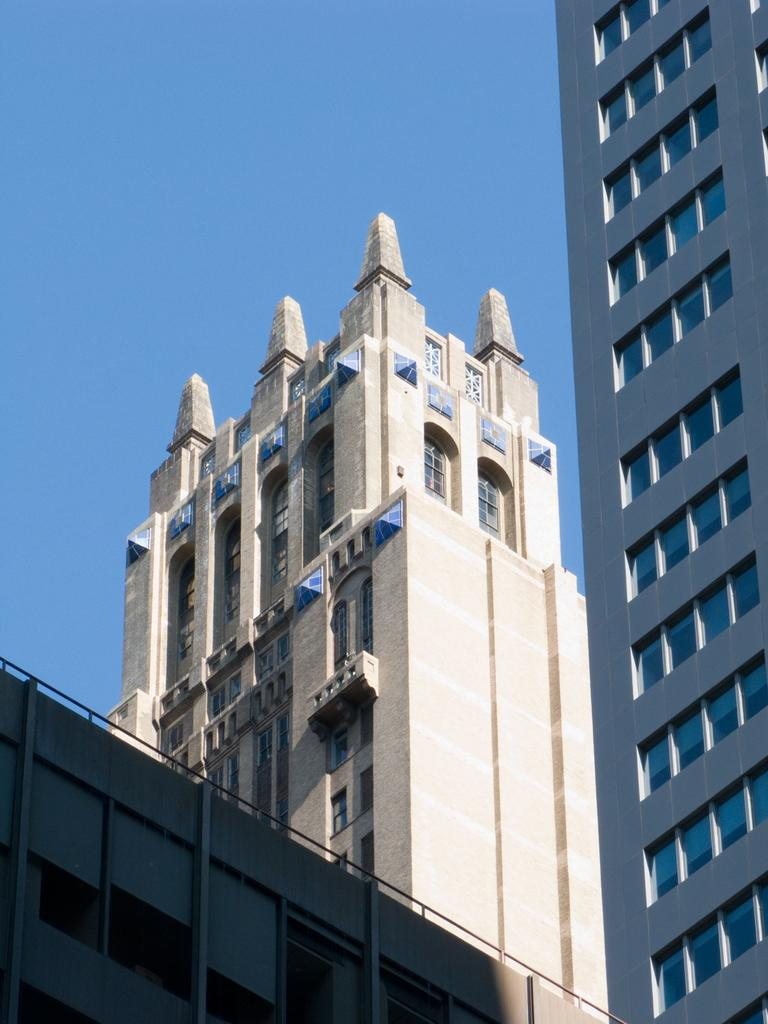What type of structures are present in the image? There are buildings in the picture. What feature do the buildings have? The buildings have windows. What material are the windows made of? The windows are made of glass. What is the condition of the sky in the image? The sky is clear in the image. Can you see any sheep in the image? There are no sheep present in the image; it features buildings with windows and a clear sky. What type of face can be seen on the buildings in the image? There are no faces present on the buildings in the image; they are simply structures with windows. 